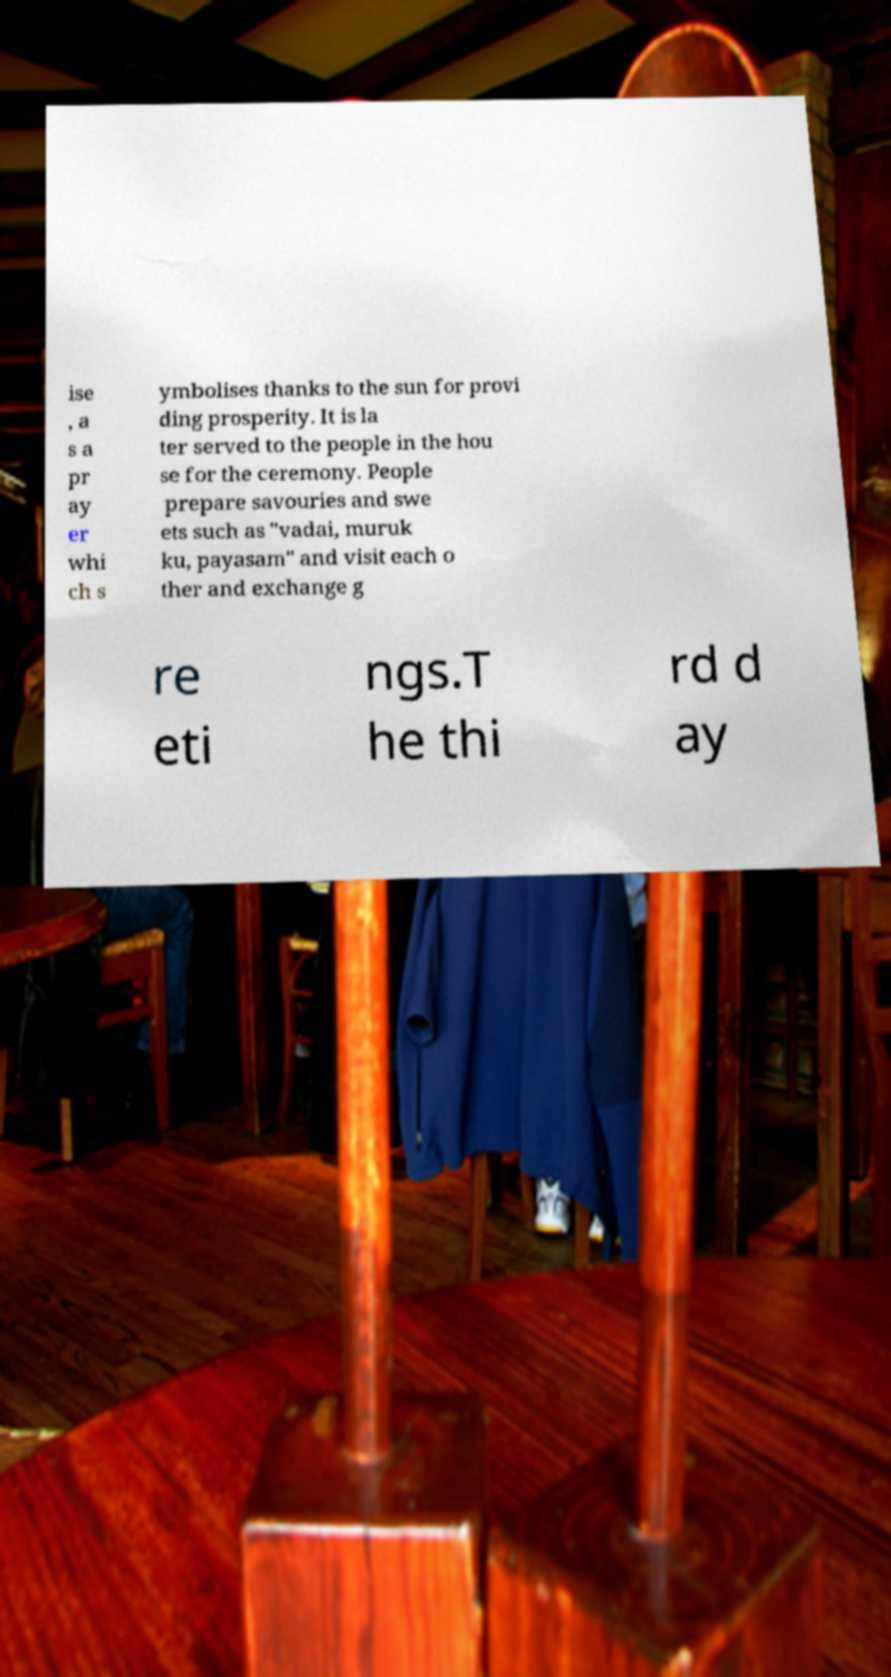Can you accurately transcribe the text from the provided image for me? ise , a s a pr ay er whi ch s ymbolises thanks to the sun for provi ding prosperity. It is la ter served to the people in the hou se for the ceremony. People prepare savouries and swe ets such as "vadai, muruk ku, payasam" and visit each o ther and exchange g re eti ngs.T he thi rd d ay 